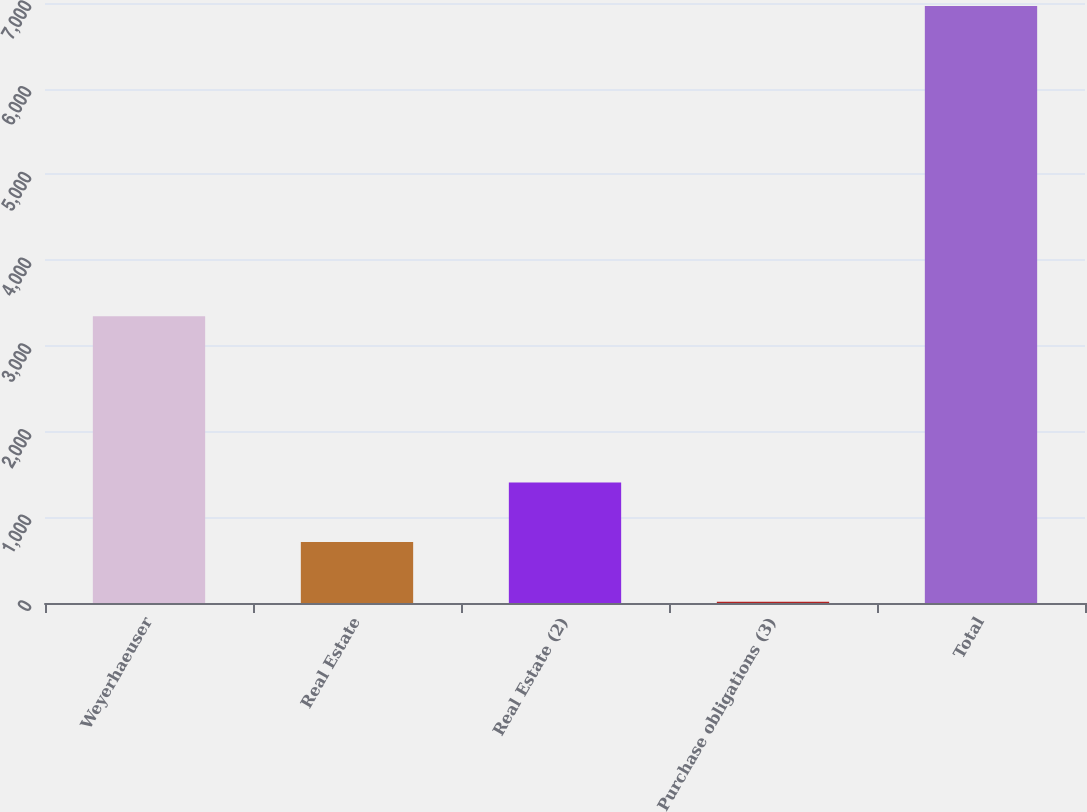Convert chart to OTSL. <chart><loc_0><loc_0><loc_500><loc_500><bar_chart><fcel>Weyerhaeuser<fcel>Real Estate<fcel>Real Estate (2)<fcel>Purchase obligations (3)<fcel>Total<nl><fcel>3346<fcel>711<fcel>1406<fcel>16<fcel>6966<nl></chart> 